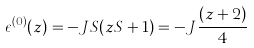Convert formula to latex. <formula><loc_0><loc_0><loc_500><loc_500>\epsilon ^ { ( 0 ) } ( z ) = - J S ( z S + 1 ) = - J \frac { ( z + 2 ) } { 4 }</formula> 